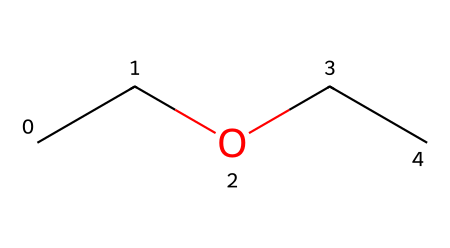What is the name of this chemical? The provided SMILES representation (CCOCC) corresponds to diethyl ether, which is recognized as a common solvent and is part of the ether class of compounds.
Answer: diethyl ether How many carbon atoms are in the chemical structure? Analyzing the SMILES code, "CC" indicates two carbon atoms from the first part and "CC" from the second part, totaling four carbon atoms in diethyl ether.
Answer: 4 What type of functional group is present in this chemical? The presence of an oxygen atom connected to two carbon chains (R-O-R) indicates that this compound contains an ether functional group, which defines ethers.
Answer: ether How many hydrogen atoms are attached to this molecule? Each carbon atom in diethyl ether typically forms four bonds. Given the four carbon atoms, calculating their hydrogen atoms (two per carbon plus two due to the oxygen) yields a total of ten hydrogen atoms.
Answer: 10 What is the main use of diethyl ether in industrial applications? Diethyl ether is primarily used as a solvent in various industrial applications, including degreasing and extraction processes due to its efficacy in dissolving organic compounds.
Answer: solvent What is the molecular formula of this chemical? By analyzing the components from the SMILES representation, we find there are 4 carbon atoms, 10 hydrogen atoms, and 1 oxygen atom, forming the molecular formula C4H10O.
Answer: C4H10O Is diethyl ether considered flammable? Yes, due to its low flash point and volatility, diethyl ether is classified as a highly flammable substance, posing risks in storage and handling.
Answer: Yes 